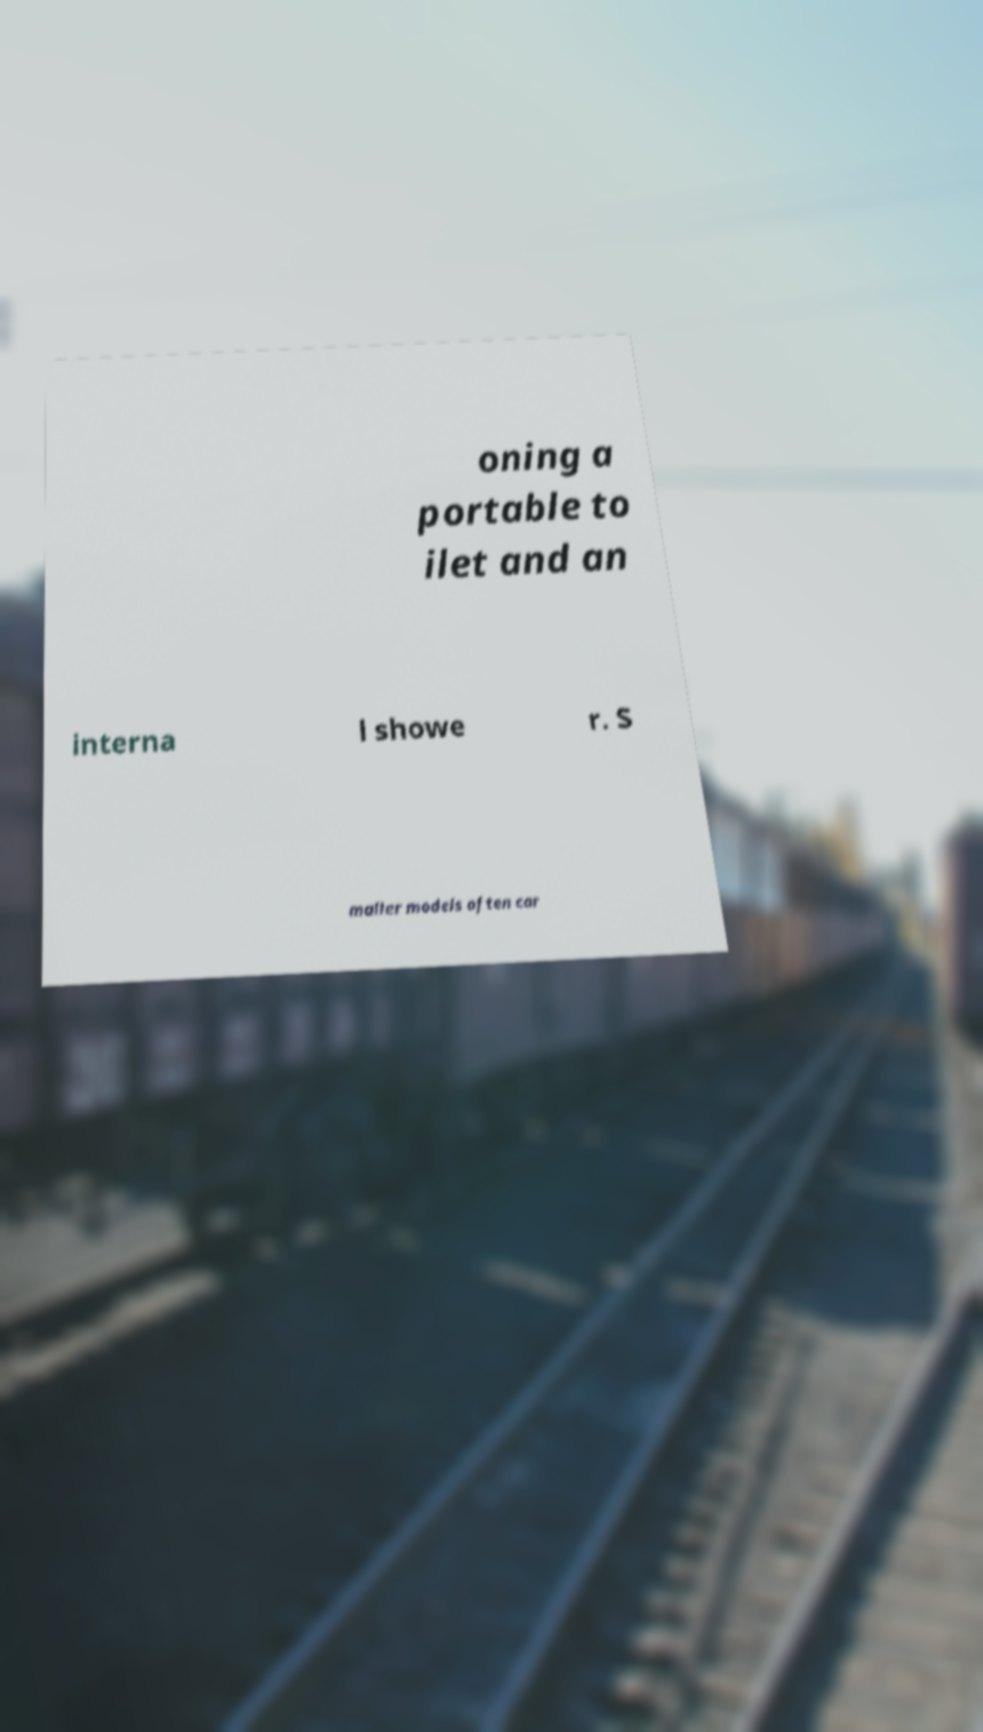Can you accurately transcribe the text from the provided image for me? oning a portable to ilet and an interna l showe r. S maller models often car 